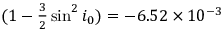<formula> <loc_0><loc_0><loc_500><loc_500>( 1 - { \frac { 3 } { 2 } } \sin ^ { 2 } i _ { 0 } ) = - 6 . 5 2 \times 1 0 ^ { - 3 }</formula> 